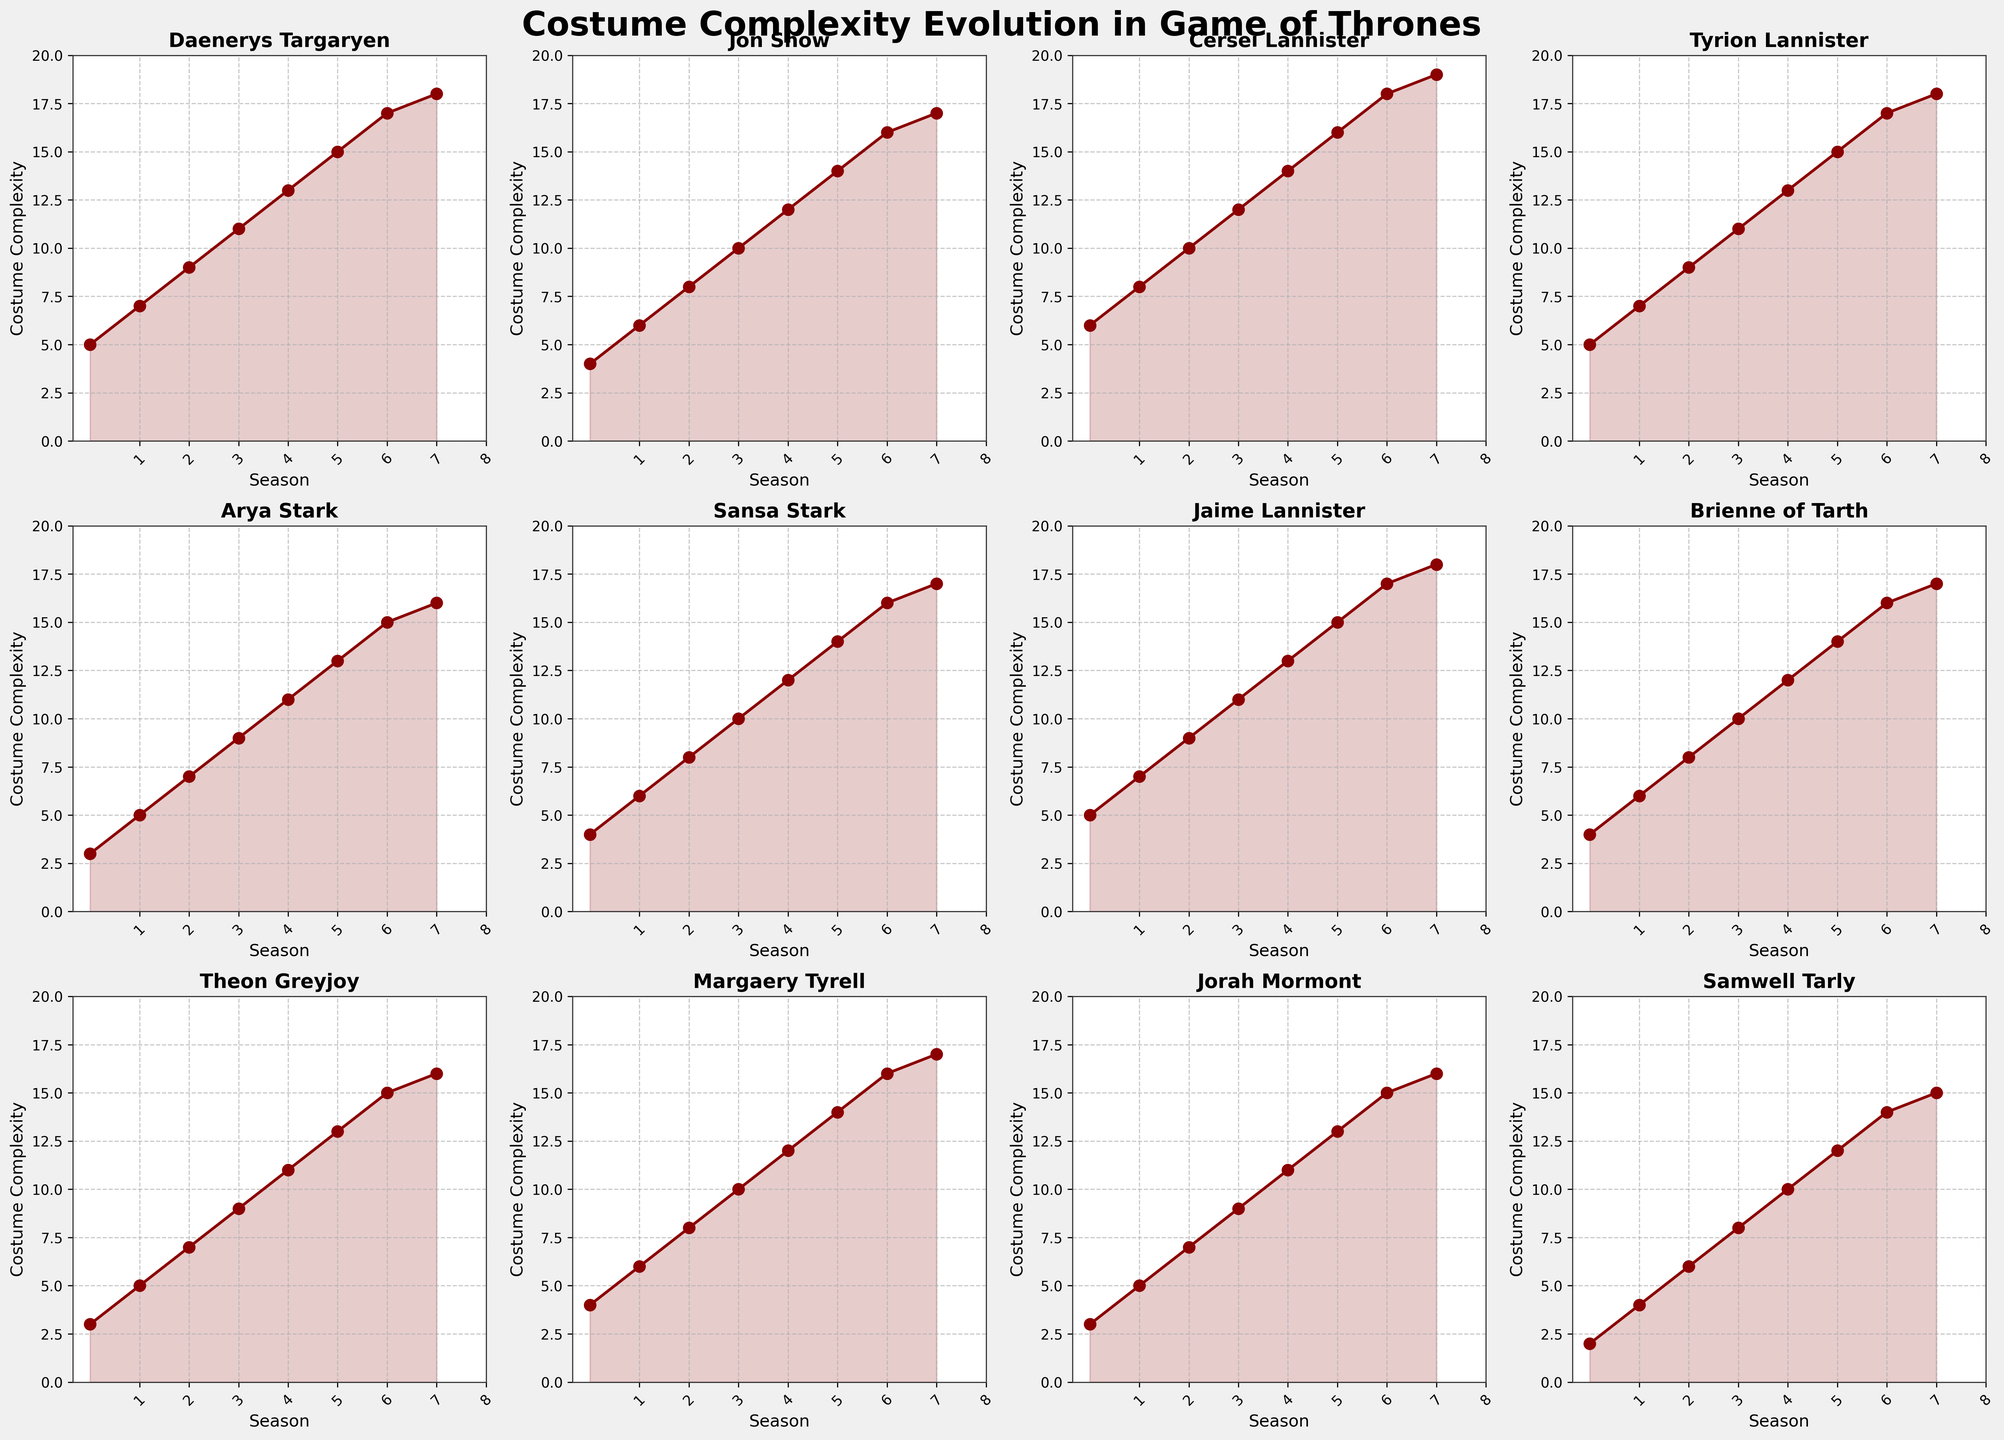how does the costume complexity of Daenerys Targaryen in Season 1 compare to Season 8? Look at the plots for both seasons and compare the values, with Season 1 at 5 and Season 8 at 18.
Answer: Her costume complexity increased by 13 elements Which character showed the highest increase in costume complexity between Seasons 4 and 8? Measure the difference in complexity for each character from Season 4 to Season 8 and identify the largest increase. For instance, Daenerys Targaryen increased from 11 to 18, a difference of 7.
Answer: Cersei Lannister Is there any character whose costume complexity remains the same between any two consecutive seasons? Analyze the line plot for each character and see if it remains flat between any two seasons.
Answer: No, all characters show changes in costume complexity every season How does Jon Snow's costume complexity change from Season 3 to Season 5? Look at Jon Snow's plot and note the values for Season 3, Season 4, and Season 5—these are 8, 10, and 12 respectively.
Answer: It increases by 4 elements What range of the y-axis is used to display the costume complexity for all characters? Observe the y-axis labels on the plots to note the range.
Answer: 0 to 20 